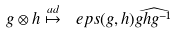Convert formula to latex. <formula><loc_0><loc_0><loc_500><loc_500>g \otimes h \stackrel { a d } { \mapsto } \ e p s ( g , h ) \widehat { g h g ^ { - 1 } }</formula> 